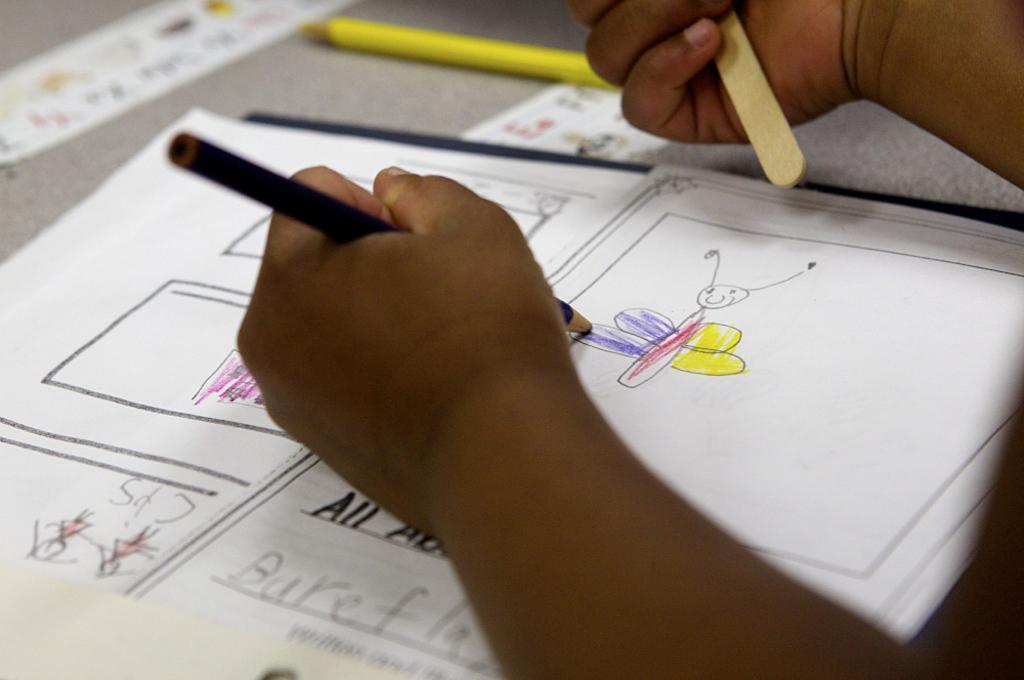What is the word under the child's arm?
Keep it short and to the point. All. What is the first letter you can see written under the word "all"?
Give a very brief answer. B. 